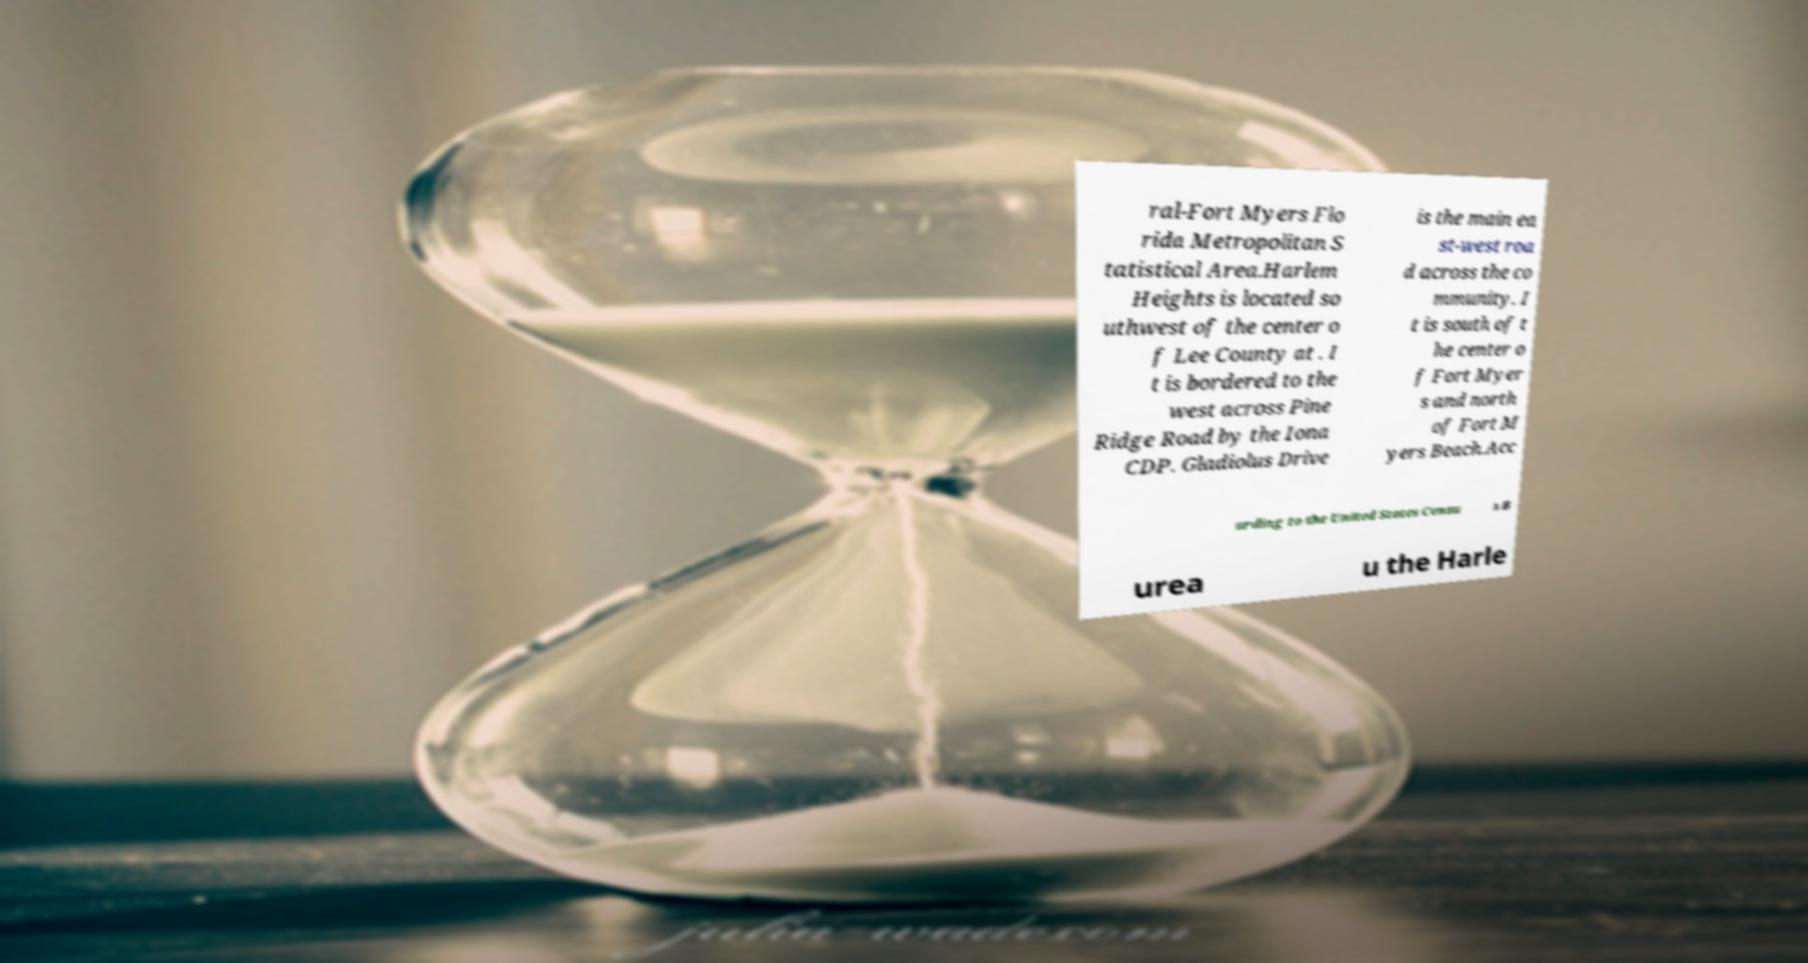Could you extract and type out the text from this image? ral-Fort Myers Flo rida Metropolitan S tatistical Area.Harlem Heights is located so uthwest of the center o f Lee County at . I t is bordered to the west across Pine Ridge Road by the Iona CDP. Gladiolus Drive is the main ea st-west roa d across the co mmunity. I t is south of t he center o f Fort Myer s and north of Fort M yers Beach.Acc ording to the United States Censu s B urea u the Harle 